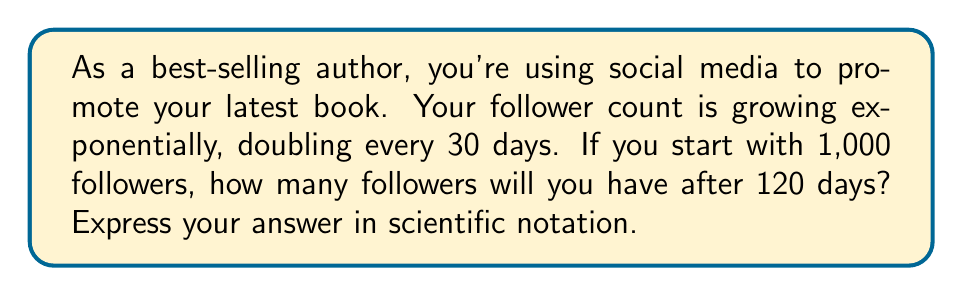Show me your answer to this math problem. Let's approach this step-by-step:

1) First, we need to determine how many times the follower count will double in 120 days.
   $\text{Number of doublings} = \frac{\text{Total time}}{\text{Doubling time}} = \frac{120 \text{ days}}{30 \text{ days}} = 4$

2) Now, we can express this as an exponential growth equation:
   $\text{Final followers} = \text{Initial followers} \times 2^{\text{Number of doublings}}$

3) Substituting our values:
   $\text{Final followers} = 1,000 \times 2^4$

4) Calculate $2^4$:
   $2^4 = 2 \times 2 \times 2 \times 2 = 16$

5) Multiply:
   $1,000 \times 16 = 16,000$

6) Convert to scientific notation:
   $16,000 = 1.6 \times 10^4$

Therefore, after 120 days, you will have $1.6 \times 10^4$ followers.
Answer: $1.6 \times 10^4$ 